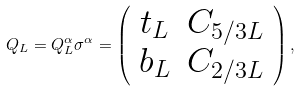<formula> <loc_0><loc_0><loc_500><loc_500>Q _ { L } = Q _ { L } ^ { \alpha } \sigma ^ { \alpha } = \left ( \begin{array} { c c } t _ { L } & C _ { 5 / 3 L } \\ b _ { L } & C _ { 2 / 3 L } \end{array} \right ) ,</formula> 